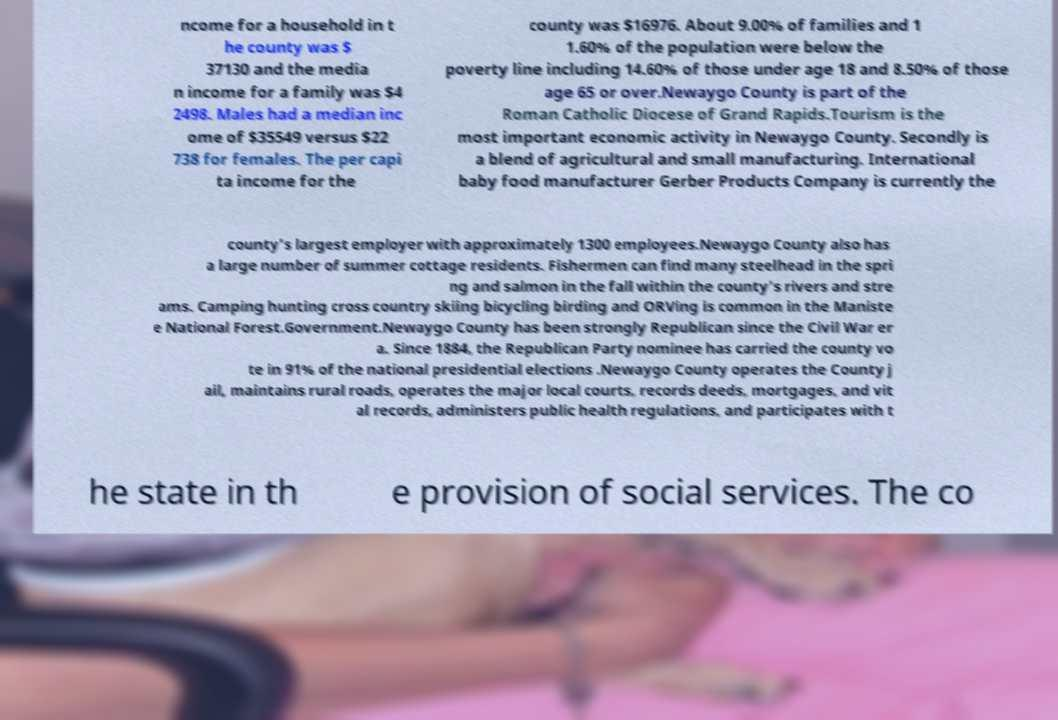What messages or text are displayed in this image? I need them in a readable, typed format. ncome for a household in t he county was $ 37130 and the media n income for a family was $4 2498. Males had a median inc ome of $35549 versus $22 738 for females. The per capi ta income for the county was $16976. About 9.00% of families and 1 1.60% of the population were below the poverty line including 14.60% of those under age 18 and 8.50% of those age 65 or over.Newaygo County is part of the Roman Catholic Diocese of Grand Rapids.Tourism is the most important economic activity in Newaygo County. Secondly is a blend of agricultural and small manufacturing. International baby food manufacturer Gerber Products Company is currently the county's largest employer with approximately 1300 employees.Newaygo County also has a large number of summer cottage residents. Fishermen can find many steelhead in the spri ng and salmon in the fall within the county's rivers and stre ams. Camping hunting cross country skiing bicycling birding and ORVing is common in the Maniste e National Forest.Government.Newaygo County has been strongly Republican since the Civil War er a. Since 1884, the Republican Party nominee has carried the county vo te in 91% of the national presidential elections .Newaygo County operates the County j ail, maintains rural roads, operates the major local courts, records deeds, mortgages, and vit al records, administers public health regulations, and participates with t he state in th e provision of social services. The co 